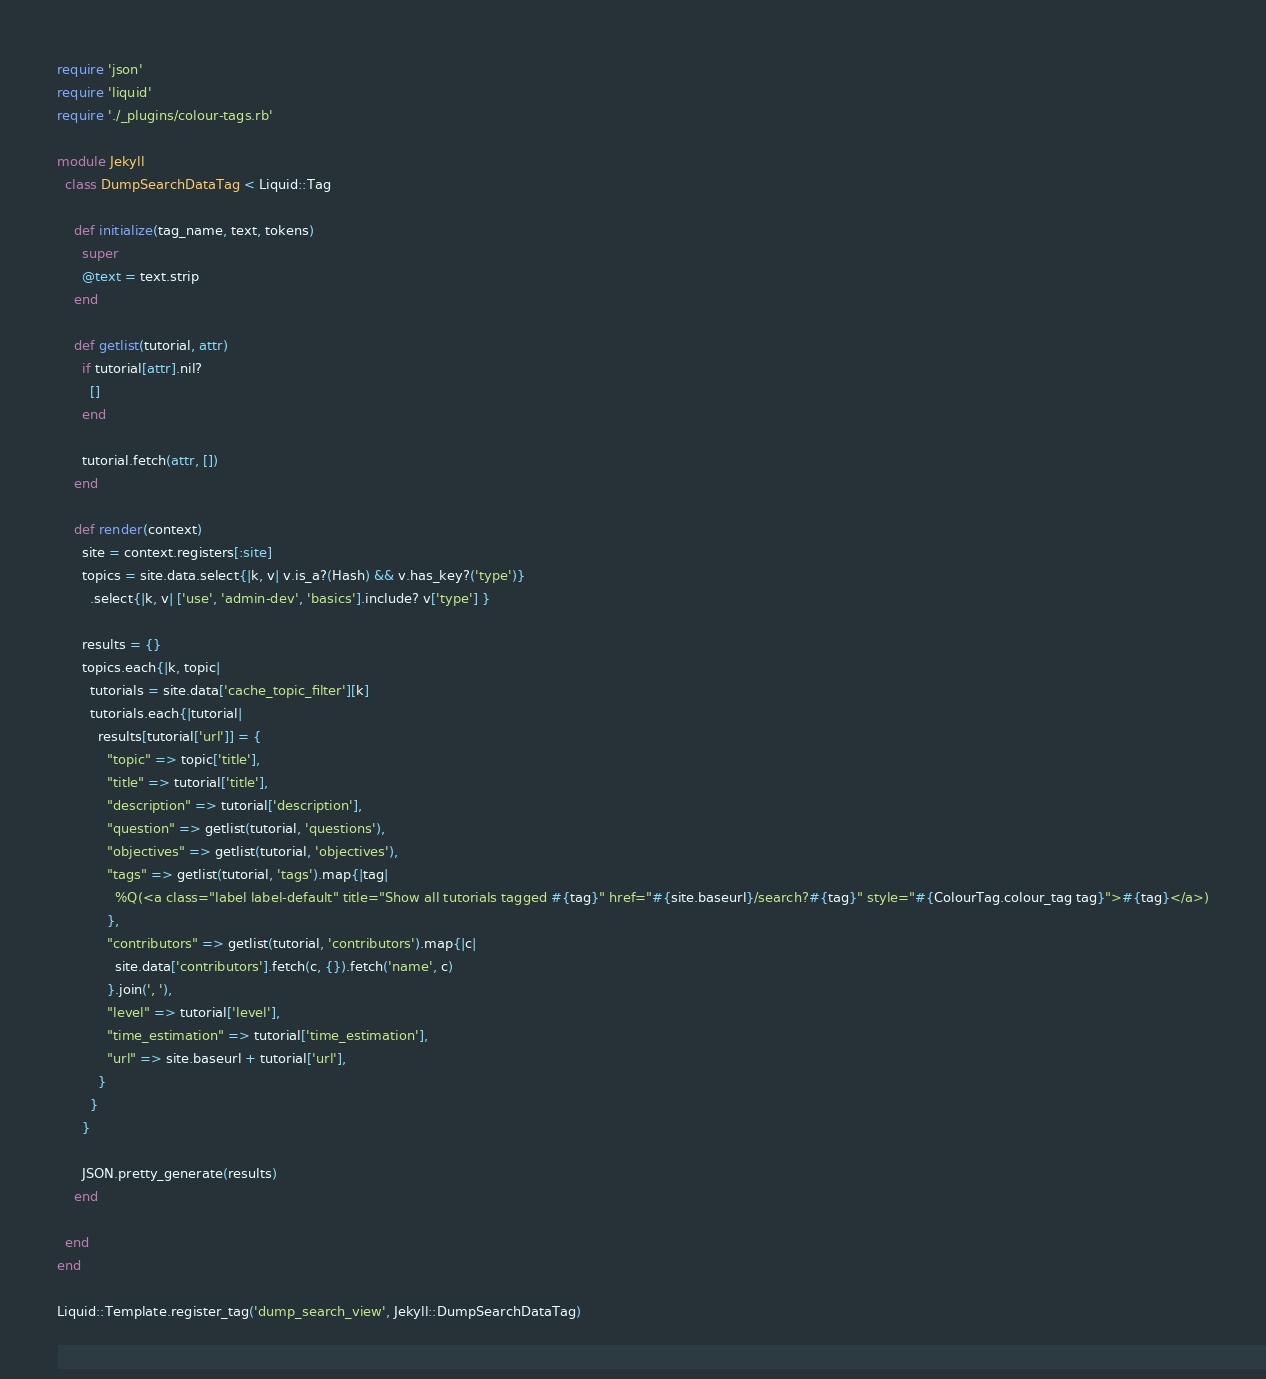Convert code to text. <code><loc_0><loc_0><loc_500><loc_500><_Ruby_>require 'json'
require 'liquid'
require './_plugins/colour-tags.rb'

module Jekyll
  class DumpSearchDataTag < Liquid::Tag

    def initialize(tag_name, text, tokens)
      super
      @text = text.strip
    end

    def getlist(tutorial, attr)
      if tutorial[attr].nil?
        []
      end

      tutorial.fetch(attr, [])
    end

    def render(context)
      site = context.registers[:site]
      topics = site.data.select{|k, v| v.is_a?(Hash) && v.has_key?('type')}
        .select{|k, v| ['use', 'admin-dev', 'basics'].include? v['type'] }

      results = {}
      topics.each{|k, topic|
        tutorials = site.data['cache_topic_filter'][k]
        tutorials.each{|tutorial|
          results[tutorial['url']] = {
            "topic" => topic['title'],
            "title" => tutorial['title'],
            "description" => tutorial['description'],
            "question" => getlist(tutorial, 'questions'),
            "objectives" => getlist(tutorial, 'objectives'),
            "tags" => getlist(tutorial, 'tags').map{|tag|
              %Q(<a class="label label-default" title="Show all tutorials tagged #{tag}" href="#{site.baseurl}/search?#{tag}" style="#{ColourTag.colour_tag tag}">#{tag}</a>)
            },
            "contributors" => getlist(tutorial, 'contributors').map{|c|
              site.data['contributors'].fetch(c, {}).fetch('name', c)
            }.join(', '),
            "level" => tutorial['level'],
            "time_estimation" => tutorial['time_estimation'],
            "url" => site.baseurl + tutorial['url'],
          }
        }
      }

      JSON.pretty_generate(results)
    end

  end
end

Liquid::Template.register_tag('dump_search_view', Jekyll::DumpSearchDataTag)
</code> 